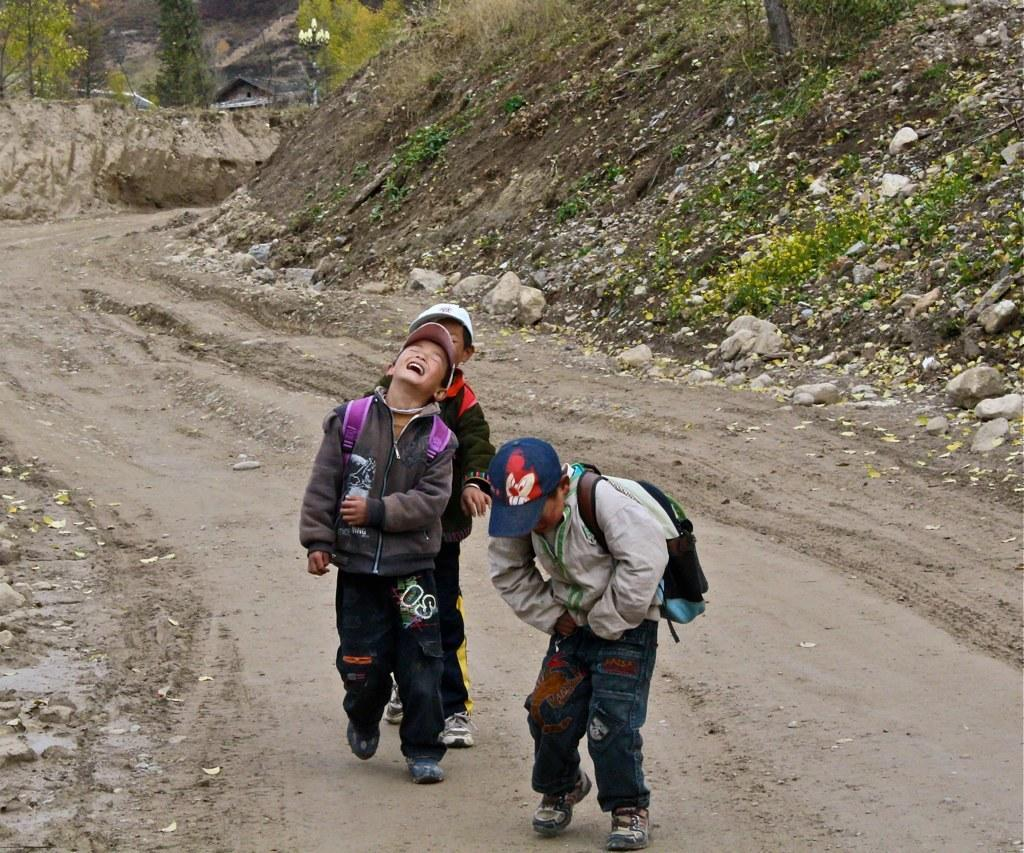How many boys are in the image? There are three boys in the image. What are the boys carrying on their backs? The boys are carrying backpacks on their backs. What are the boys doing in the image? The boys are walking on a road. What can be seen in the background of the image? There are trees visible in the image. Where is the cave located in the image? There is no cave present in the image. What type of coil is wrapped around the boys' legs in the image? There is no coil wrapped around the boys' legs in the image. 